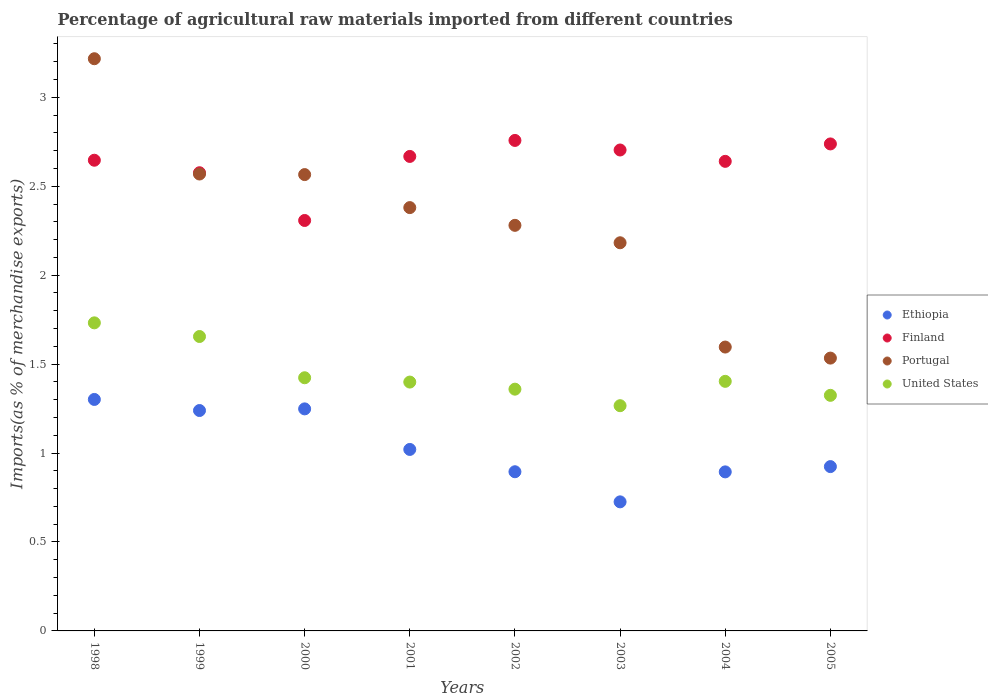How many different coloured dotlines are there?
Ensure brevity in your answer.  4. What is the percentage of imports to different countries in United States in 1999?
Ensure brevity in your answer.  1.66. Across all years, what is the maximum percentage of imports to different countries in Portugal?
Provide a short and direct response. 3.22. Across all years, what is the minimum percentage of imports to different countries in Portugal?
Your response must be concise. 1.53. In which year was the percentage of imports to different countries in Ethiopia minimum?
Offer a very short reply. 2003. What is the total percentage of imports to different countries in Finland in the graph?
Your answer should be compact. 21.04. What is the difference between the percentage of imports to different countries in Finland in 1998 and that in 2005?
Ensure brevity in your answer.  -0.09. What is the difference between the percentage of imports to different countries in Finland in 1999 and the percentage of imports to different countries in United States in 2000?
Provide a short and direct response. 1.15. What is the average percentage of imports to different countries in Portugal per year?
Make the answer very short. 2.29. In the year 2001, what is the difference between the percentage of imports to different countries in United States and percentage of imports to different countries in Finland?
Provide a short and direct response. -1.27. In how many years, is the percentage of imports to different countries in United States greater than 1.1 %?
Offer a very short reply. 8. What is the ratio of the percentage of imports to different countries in Portugal in 2001 to that in 2005?
Keep it short and to the point. 1.55. Is the percentage of imports to different countries in United States in 2002 less than that in 2003?
Provide a short and direct response. No. What is the difference between the highest and the second highest percentage of imports to different countries in Ethiopia?
Offer a terse response. 0.05. What is the difference between the highest and the lowest percentage of imports to different countries in Portugal?
Provide a succinct answer. 1.68. Is the sum of the percentage of imports to different countries in Portugal in 2001 and 2005 greater than the maximum percentage of imports to different countries in Finland across all years?
Offer a terse response. Yes. Is it the case that in every year, the sum of the percentage of imports to different countries in United States and percentage of imports to different countries in Portugal  is greater than the sum of percentage of imports to different countries in Finland and percentage of imports to different countries in Ethiopia?
Offer a terse response. No. Does the percentage of imports to different countries in Portugal monotonically increase over the years?
Your answer should be very brief. No. What is the difference between two consecutive major ticks on the Y-axis?
Offer a very short reply. 0.5. Are the values on the major ticks of Y-axis written in scientific E-notation?
Your answer should be compact. No. Does the graph contain any zero values?
Your response must be concise. No. How many legend labels are there?
Provide a short and direct response. 4. What is the title of the graph?
Offer a terse response. Percentage of agricultural raw materials imported from different countries. What is the label or title of the X-axis?
Offer a very short reply. Years. What is the label or title of the Y-axis?
Offer a very short reply. Imports(as % of merchandise exports). What is the Imports(as % of merchandise exports) in Ethiopia in 1998?
Provide a succinct answer. 1.3. What is the Imports(as % of merchandise exports) of Finland in 1998?
Keep it short and to the point. 2.65. What is the Imports(as % of merchandise exports) of Portugal in 1998?
Your response must be concise. 3.22. What is the Imports(as % of merchandise exports) of United States in 1998?
Your response must be concise. 1.73. What is the Imports(as % of merchandise exports) of Ethiopia in 1999?
Give a very brief answer. 1.24. What is the Imports(as % of merchandise exports) in Finland in 1999?
Make the answer very short. 2.58. What is the Imports(as % of merchandise exports) in Portugal in 1999?
Your answer should be compact. 2.57. What is the Imports(as % of merchandise exports) of United States in 1999?
Make the answer very short. 1.66. What is the Imports(as % of merchandise exports) in Ethiopia in 2000?
Make the answer very short. 1.25. What is the Imports(as % of merchandise exports) of Finland in 2000?
Your answer should be compact. 2.31. What is the Imports(as % of merchandise exports) in Portugal in 2000?
Provide a short and direct response. 2.57. What is the Imports(as % of merchandise exports) of United States in 2000?
Give a very brief answer. 1.42. What is the Imports(as % of merchandise exports) in Ethiopia in 2001?
Offer a very short reply. 1.02. What is the Imports(as % of merchandise exports) in Finland in 2001?
Your answer should be compact. 2.67. What is the Imports(as % of merchandise exports) in Portugal in 2001?
Provide a short and direct response. 2.38. What is the Imports(as % of merchandise exports) in United States in 2001?
Make the answer very short. 1.4. What is the Imports(as % of merchandise exports) of Ethiopia in 2002?
Your response must be concise. 0.89. What is the Imports(as % of merchandise exports) of Finland in 2002?
Give a very brief answer. 2.76. What is the Imports(as % of merchandise exports) in Portugal in 2002?
Make the answer very short. 2.28. What is the Imports(as % of merchandise exports) in United States in 2002?
Give a very brief answer. 1.36. What is the Imports(as % of merchandise exports) in Ethiopia in 2003?
Offer a very short reply. 0.73. What is the Imports(as % of merchandise exports) of Finland in 2003?
Provide a short and direct response. 2.7. What is the Imports(as % of merchandise exports) in Portugal in 2003?
Offer a terse response. 2.18. What is the Imports(as % of merchandise exports) of United States in 2003?
Provide a succinct answer. 1.27. What is the Imports(as % of merchandise exports) in Ethiopia in 2004?
Offer a terse response. 0.89. What is the Imports(as % of merchandise exports) in Finland in 2004?
Ensure brevity in your answer.  2.64. What is the Imports(as % of merchandise exports) of Portugal in 2004?
Your response must be concise. 1.6. What is the Imports(as % of merchandise exports) in United States in 2004?
Give a very brief answer. 1.4. What is the Imports(as % of merchandise exports) of Ethiopia in 2005?
Give a very brief answer. 0.92. What is the Imports(as % of merchandise exports) of Finland in 2005?
Provide a succinct answer. 2.74. What is the Imports(as % of merchandise exports) in Portugal in 2005?
Keep it short and to the point. 1.53. What is the Imports(as % of merchandise exports) of United States in 2005?
Your response must be concise. 1.32. Across all years, what is the maximum Imports(as % of merchandise exports) in Ethiopia?
Your response must be concise. 1.3. Across all years, what is the maximum Imports(as % of merchandise exports) of Finland?
Provide a short and direct response. 2.76. Across all years, what is the maximum Imports(as % of merchandise exports) in Portugal?
Offer a very short reply. 3.22. Across all years, what is the maximum Imports(as % of merchandise exports) in United States?
Give a very brief answer. 1.73. Across all years, what is the minimum Imports(as % of merchandise exports) in Ethiopia?
Your response must be concise. 0.73. Across all years, what is the minimum Imports(as % of merchandise exports) of Finland?
Provide a short and direct response. 2.31. Across all years, what is the minimum Imports(as % of merchandise exports) of Portugal?
Ensure brevity in your answer.  1.53. Across all years, what is the minimum Imports(as % of merchandise exports) in United States?
Keep it short and to the point. 1.27. What is the total Imports(as % of merchandise exports) of Ethiopia in the graph?
Your answer should be compact. 8.25. What is the total Imports(as % of merchandise exports) in Finland in the graph?
Your response must be concise. 21.04. What is the total Imports(as % of merchandise exports) in Portugal in the graph?
Your response must be concise. 18.32. What is the total Imports(as % of merchandise exports) of United States in the graph?
Your response must be concise. 11.56. What is the difference between the Imports(as % of merchandise exports) in Ethiopia in 1998 and that in 1999?
Your answer should be very brief. 0.06. What is the difference between the Imports(as % of merchandise exports) of Finland in 1998 and that in 1999?
Your answer should be compact. 0.07. What is the difference between the Imports(as % of merchandise exports) in Portugal in 1998 and that in 1999?
Provide a succinct answer. 0.65. What is the difference between the Imports(as % of merchandise exports) of United States in 1998 and that in 1999?
Offer a terse response. 0.08. What is the difference between the Imports(as % of merchandise exports) of Ethiopia in 1998 and that in 2000?
Ensure brevity in your answer.  0.05. What is the difference between the Imports(as % of merchandise exports) of Finland in 1998 and that in 2000?
Your response must be concise. 0.34. What is the difference between the Imports(as % of merchandise exports) in Portugal in 1998 and that in 2000?
Ensure brevity in your answer.  0.65. What is the difference between the Imports(as % of merchandise exports) of United States in 1998 and that in 2000?
Your response must be concise. 0.31. What is the difference between the Imports(as % of merchandise exports) in Ethiopia in 1998 and that in 2001?
Offer a terse response. 0.28. What is the difference between the Imports(as % of merchandise exports) in Finland in 1998 and that in 2001?
Ensure brevity in your answer.  -0.02. What is the difference between the Imports(as % of merchandise exports) of Portugal in 1998 and that in 2001?
Offer a terse response. 0.84. What is the difference between the Imports(as % of merchandise exports) of United States in 1998 and that in 2001?
Provide a short and direct response. 0.33. What is the difference between the Imports(as % of merchandise exports) of Ethiopia in 1998 and that in 2002?
Provide a short and direct response. 0.41. What is the difference between the Imports(as % of merchandise exports) in Finland in 1998 and that in 2002?
Make the answer very short. -0.11. What is the difference between the Imports(as % of merchandise exports) in Portugal in 1998 and that in 2002?
Provide a short and direct response. 0.94. What is the difference between the Imports(as % of merchandise exports) of United States in 1998 and that in 2002?
Your answer should be compact. 0.37. What is the difference between the Imports(as % of merchandise exports) of Ethiopia in 1998 and that in 2003?
Your answer should be very brief. 0.58. What is the difference between the Imports(as % of merchandise exports) in Finland in 1998 and that in 2003?
Offer a terse response. -0.06. What is the difference between the Imports(as % of merchandise exports) in Portugal in 1998 and that in 2003?
Your answer should be compact. 1.03. What is the difference between the Imports(as % of merchandise exports) in United States in 1998 and that in 2003?
Your answer should be compact. 0.47. What is the difference between the Imports(as % of merchandise exports) in Ethiopia in 1998 and that in 2004?
Offer a terse response. 0.41. What is the difference between the Imports(as % of merchandise exports) of Finland in 1998 and that in 2004?
Provide a short and direct response. 0.01. What is the difference between the Imports(as % of merchandise exports) of Portugal in 1998 and that in 2004?
Your answer should be compact. 1.62. What is the difference between the Imports(as % of merchandise exports) of United States in 1998 and that in 2004?
Give a very brief answer. 0.33. What is the difference between the Imports(as % of merchandise exports) in Ethiopia in 1998 and that in 2005?
Offer a very short reply. 0.38. What is the difference between the Imports(as % of merchandise exports) in Finland in 1998 and that in 2005?
Offer a very short reply. -0.09. What is the difference between the Imports(as % of merchandise exports) in Portugal in 1998 and that in 2005?
Ensure brevity in your answer.  1.68. What is the difference between the Imports(as % of merchandise exports) of United States in 1998 and that in 2005?
Make the answer very short. 0.41. What is the difference between the Imports(as % of merchandise exports) of Ethiopia in 1999 and that in 2000?
Your response must be concise. -0.01. What is the difference between the Imports(as % of merchandise exports) in Finland in 1999 and that in 2000?
Offer a very short reply. 0.27. What is the difference between the Imports(as % of merchandise exports) of Portugal in 1999 and that in 2000?
Provide a short and direct response. 0. What is the difference between the Imports(as % of merchandise exports) in United States in 1999 and that in 2000?
Keep it short and to the point. 0.23. What is the difference between the Imports(as % of merchandise exports) in Ethiopia in 1999 and that in 2001?
Your answer should be very brief. 0.22. What is the difference between the Imports(as % of merchandise exports) in Finland in 1999 and that in 2001?
Make the answer very short. -0.09. What is the difference between the Imports(as % of merchandise exports) in Portugal in 1999 and that in 2001?
Offer a very short reply. 0.19. What is the difference between the Imports(as % of merchandise exports) in United States in 1999 and that in 2001?
Give a very brief answer. 0.26. What is the difference between the Imports(as % of merchandise exports) of Ethiopia in 1999 and that in 2002?
Provide a succinct answer. 0.34. What is the difference between the Imports(as % of merchandise exports) in Finland in 1999 and that in 2002?
Ensure brevity in your answer.  -0.18. What is the difference between the Imports(as % of merchandise exports) in Portugal in 1999 and that in 2002?
Your response must be concise. 0.29. What is the difference between the Imports(as % of merchandise exports) of United States in 1999 and that in 2002?
Make the answer very short. 0.3. What is the difference between the Imports(as % of merchandise exports) in Ethiopia in 1999 and that in 2003?
Provide a succinct answer. 0.51. What is the difference between the Imports(as % of merchandise exports) in Finland in 1999 and that in 2003?
Provide a short and direct response. -0.13. What is the difference between the Imports(as % of merchandise exports) of Portugal in 1999 and that in 2003?
Provide a short and direct response. 0.39. What is the difference between the Imports(as % of merchandise exports) of United States in 1999 and that in 2003?
Offer a very short reply. 0.39. What is the difference between the Imports(as % of merchandise exports) in Ethiopia in 1999 and that in 2004?
Offer a terse response. 0.34. What is the difference between the Imports(as % of merchandise exports) in Finland in 1999 and that in 2004?
Offer a terse response. -0.06. What is the difference between the Imports(as % of merchandise exports) of Portugal in 1999 and that in 2004?
Ensure brevity in your answer.  0.97. What is the difference between the Imports(as % of merchandise exports) of United States in 1999 and that in 2004?
Offer a very short reply. 0.25. What is the difference between the Imports(as % of merchandise exports) of Ethiopia in 1999 and that in 2005?
Offer a terse response. 0.32. What is the difference between the Imports(as % of merchandise exports) of Finland in 1999 and that in 2005?
Provide a short and direct response. -0.16. What is the difference between the Imports(as % of merchandise exports) of Portugal in 1999 and that in 2005?
Make the answer very short. 1.03. What is the difference between the Imports(as % of merchandise exports) in United States in 1999 and that in 2005?
Your response must be concise. 0.33. What is the difference between the Imports(as % of merchandise exports) in Ethiopia in 2000 and that in 2001?
Give a very brief answer. 0.23. What is the difference between the Imports(as % of merchandise exports) in Finland in 2000 and that in 2001?
Offer a terse response. -0.36. What is the difference between the Imports(as % of merchandise exports) in Portugal in 2000 and that in 2001?
Give a very brief answer. 0.19. What is the difference between the Imports(as % of merchandise exports) of United States in 2000 and that in 2001?
Offer a terse response. 0.02. What is the difference between the Imports(as % of merchandise exports) in Ethiopia in 2000 and that in 2002?
Offer a terse response. 0.35. What is the difference between the Imports(as % of merchandise exports) of Finland in 2000 and that in 2002?
Provide a short and direct response. -0.45. What is the difference between the Imports(as % of merchandise exports) in Portugal in 2000 and that in 2002?
Keep it short and to the point. 0.29. What is the difference between the Imports(as % of merchandise exports) of United States in 2000 and that in 2002?
Ensure brevity in your answer.  0.06. What is the difference between the Imports(as % of merchandise exports) of Ethiopia in 2000 and that in 2003?
Your answer should be compact. 0.52. What is the difference between the Imports(as % of merchandise exports) in Finland in 2000 and that in 2003?
Keep it short and to the point. -0.4. What is the difference between the Imports(as % of merchandise exports) in Portugal in 2000 and that in 2003?
Offer a terse response. 0.38. What is the difference between the Imports(as % of merchandise exports) in United States in 2000 and that in 2003?
Offer a very short reply. 0.16. What is the difference between the Imports(as % of merchandise exports) in Ethiopia in 2000 and that in 2004?
Give a very brief answer. 0.35. What is the difference between the Imports(as % of merchandise exports) in Finland in 2000 and that in 2004?
Your answer should be compact. -0.33. What is the difference between the Imports(as % of merchandise exports) in Portugal in 2000 and that in 2004?
Ensure brevity in your answer.  0.97. What is the difference between the Imports(as % of merchandise exports) of United States in 2000 and that in 2004?
Your response must be concise. 0.02. What is the difference between the Imports(as % of merchandise exports) of Ethiopia in 2000 and that in 2005?
Ensure brevity in your answer.  0.32. What is the difference between the Imports(as % of merchandise exports) of Finland in 2000 and that in 2005?
Provide a short and direct response. -0.43. What is the difference between the Imports(as % of merchandise exports) in Portugal in 2000 and that in 2005?
Provide a short and direct response. 1.03. What is the difference between the Imports(as % of merchandise exports) of United States in 2000 and that in 2005?
Make the answer very short. 0.1. What is the difference between the Imports(as % of merchandise exports) in Ethiopia in 2001 and that in 2002?
Make the answer very short. 0.13. What is the difference between the Imports(as % of merchandise exports) in Finland in 2001 and that in 2002?
Provide a succinct answer. -0.09. What is the difference between the Imports(as % of merchandise exports) of Portugal in 2001 and that in 2002?
Provide a short and direct response. 0.1. What is the difference between the Imports(as % of merchandise exports) in United States in 2001 and that in 2002?
Ensure brevity in your answer.  0.04. What is the difference between the Imports(as % of merchandise exports) of Ethiopia in 2001 and that in 2003?
Ensure brevity in your answer.  0.29. What is the difference between the Imports(as % of merchandise exports) of Finland in 2001 and that in 2003?
Ensure brevity in your answer.  -0.04. What is the difference between the Imports(as % of merchandise exports) in Portugal in 2001 and that in 2003?
Your response must be concise. 0.2. What is the difference between the Imports(as % of merchandise exports) in United States in 2001 and that in 2003?
Provide a succinct answer. 0.13. What is the difference between the Imports(as % of merchandise exports) of Ethiopia in 2001 and that in 2004?
Provide a succinct answer. 0.13. What is the difference between the Imports(as % of merchandise exports) of Finland in 2001 and that in 2004?
Ensure brevity in your answer.  0.03. What is the difference between the Imports(as % of merchandise exports) in Portugal in 2001 and that in 2004?
Provide a short and direct response. 0.78. What is the difference between the Imports(as % of merchandise exports) of United States in 2001 and that in 2004?
Keep it short and to the point. -0. What is the difference between the Imports(as % of merchandise exports) in Ethiopia in 2001 and that in 2005?
Offer a terse response. 0.1. What is the difference between the Imports(as % of merchandise exports) in Finland in 2001 and that in 2005?
Ensure brevity in your answer.  -0.07. What is the difference between the Imports(as % of merchandise exports) of Portugal in 2001 and that in 2005?
Give a very brief answer. 0.85. What is the difference between the Imports(as % of merchandise exports) of United States in 2001 and that in 2005?
Provide a succinct answer. 0.07. What is the difference between the Imports(as % of merchandise exports) in Ethiopia in 2002 and that in 2003?
Give a very brief answer. 0.17. What is the difference between the Imports(as % of merchandise exports) of Finland in 2002 and that in 2003?
Keep it short and to the point. 0.05. What is the difference between the Imports(as % of merchandise exports) of Portugal in 2002 and that in 2003?
Ensure brevity in your answer.  0.1. What is the difference between the Imports(as % of merchandise exports) of United States in 2002 and that in 2003?
Provide a succinct answer. 0.09. What is the difference between the Imports(as % of merchandise exports) in Ethiopia in 2002 and that in 2004?
Provide a short and direct response. 0. What is the difference between the Imports(as % of merchandise exports) in Finland in 2002 and that in 2004?
Offer a very short reply. 0.12. What is the difference between the Imports(as % of merchandise exports) in Portugal in 2002 and that in 2004?
Make the answer very short. 0.68. What is the difference between the Imports(as % of merchandise exports) in United States in 2002 and that in 2004?
Offer a terse response. -0.04. What is the difference between the Imports(as % of merchandise exports) in Ethiopia in 2002 and that in 2005?
Your response must be concise. -0.03. What is the difference between the Imports(as % of merchandise exports) of Finland in 2002 and that in 2005?
Your answer should be very brief. 0.02. What is the difference between the Imports(as % of merchandise exports) of Portugal in 2002 and that in 2005?
Make the answer very short. 0.75. What is the difference between the Imports(as % of merchandise exports) of United States in 2002 and that in 2005?
Provide a short and direct response. 0.03. What is the difference between the Imports(as % of merchandise exports) of Ethiopia in 2003 and that in 2004?
Your response must be concise. -0.17. What is the difference between the Imports(as % of merchandise exports) in Finland in 2003 and that in 2004?
Give a very brief answer. 0.06. What is the difference between the Imports(as % of merchandise exports) in Portugal in 2003 and that in 2004?
Your answer should be compact. 0.59. What is the difference between the Imports(as % of merchandise exports) in United States in 2003 and that in 2004?
Your response must be concise. -0.14. What is the difference between the Imports(as % of merchandise exports) in Ethiopia in 2003 and that in 2005?
Your response must be concise. -0.2. What is the difference between the Imports(as % of merchandise exports) of Finland in 2003 and that in 2005?
Provide a succinct answer. -0.03. What is the difference between the Imports(as % of merchandise exports) in Portugal in 2003 and that in 2005?
Offer a terse response. 0.65. What is the difference between the Imports(as % of merchandise exports) in United States in 2003 and that in 2005?
Your answer should be compact. -0.06. What is the difference between the Imports(as % of merchandise exports) of Ethiopia in 2004 and that in 2005?
Provide a succinct answer. -0.03. What is the difference between the Imports(as % of merchandise exports) in Finland in 2004 and that in 2005?
Offer a very short reply. -0.1. What is the difference between the Imports(as % of merchandise exports) of Portugal in 2004 and that in 2005?
Give a very brief answer. 0.06. What is the difference between the Imports(as % of merchandise exports) of United States in 2004 and that in 2005?
Your answer should be very brief. 0.08. What is the difference between the Imports(as % of merchandise exports) of Ethiopia in 1998 and the Imports(as % of merchandise exports) of Finland in 1999?
Give a very brief answer. -1.27. What is the difference between the Imports(as % of merchandise exports) in Ethiopia in 1998 and the Imports(as % of merchandise exports) in Portugal in 1999?
Your answer should be very brief. -1.27. What is the difference between the Imports(as % of merchandise exports) in Ethiopia in 1998 and the Imports(as % of merchandise exports) in United States in 1999?
Your response must be concise. -0.35. What is the difference between the Imports(as % of merchandise exports) of Finland in 1998 and the Imports(as % of merchandise exports) of Portugal in 1999?
Make the answer very short. 0.08. What is the difference between the Imports(as % of merchandise exports) in Portugal in 1998 and the Imports(as % of merchandise exports) in United States in 1999?
Your response must be concise. 1.56. What is the difference between the Imports(as % of merchandise exports) in Ethiopia in 1998 and the Imports(as % of merchandise exports) in Finland in 2000?
Give a very brief answer. -1.01. What is the difference between the Imports(as % of merchandise exports) of Ethiopia in 1998 and the Imports(as % of merchandise exports) of Portugal in 2000?
Your answer should be compact. -1.26. What is the difference between the Imports(as % of merchandise exports) in Ethiopia in 1998 and the Imports(as % of merchandise exports) in United States in 2000?
Ensure brevity in your answer.  -0.12. What is the difference between the Imports(as % of merchandise exports) of Finland in 1998 and the Imports(as % of merchandise exports) of Portugal in 2000?
Ensure brevity in your answer.  0.08. What is the difference between the Imports(as % of merchandise exports) in Finland in 1998 and the Imports(as % of merchandise exports) in United States in 2000?
Your answer should be very brief. 1.22. What is the difference between the Imports(as % of merchandise exports) of Portugal in 1998 and the Imports(as % of merchandise exports) of United States in 2000?
Provide a succinct answer. 1.79. What is the difference between the Imports(as % of merchandise exports) in Ethiopia in 1998 and the Imports(as % of merchandise exports) in Finland in 2001?
Provide a succinct answer. -1.37. What is the difference between the Imports(as % of merchandise exports) in Ethiopia in 1998 and the Imports(as % of merchandise exports) in Portugal in 2001?
Give a very brief answer. -1.08. What is the difference between the Imports(as % of merchandise exports) in Ethiopia in 1998 and the Imports(as % of merchandise exports) in United States in 2001?
Give a very brief answer. -0.1. What is the difference between the Imports(as % of merchandise exports) in Finland in 1998 and the Imports(as % of merchandise exports) in Portugal in 2001?
Provide a short and direct response. 0.27. What is the difference between the Imports(as % of merchandise exports) of Finland in 1998 and the Imports(as % of merchandise exports) of United States in 2001?
Ensure brevity in your answer.  1.25. What is the difference between the Imports(as % of merchandise exports) in Portugal in 1998 and the Imports(as % of merchandise exports) in United States in 2001?
Your response must be concise. 1.82. What is the difference between the Imports(as % of merchandise exports) in Ethiopia in 1998 and the Imports(as % of merchandise exports) in Finland in 2002?
Your response must be concise. -1.46. What is the difference between the Imports(as % of merchandise exports) in Ethiopia in 1998 and the Imports(as % of merchandise exports) in Portugal in 2002?
Your answer should be very brief. -0.98. What is the difference between the Imports(as % of merchandise exports) of Ethiopia in 1998 and the Imports(as % of merchandise exports) of United States in 2002?
Ensure brevity in your answer.  -0.06. What is the difference between the Imports(as % of merchandise exports) in Finland in 1998 and the Imports(as % of merchandise exports) in Portugal in 2002?
Ensure brevity in your answer.  0.37. What is the difference between the Imports(as % of merchandise exports) in Finland in 1998 and the Imports(as % of merchandise exports) in United States in 2002?
Give a very brief answer. 1.29. What is the difference between the Imports(as % of merchandise exports) in Portugal in 1998 and the Imports(as % of merchandise exports) in United States in 2002?
Offer a very short reply. 1.86. What is the difference between the Imports(as % of merchandise exports) in Ethiopia in 1998 and the Imports(as % of merchandise exports) in Finland in 2003?
Give a very brief answer. -1.4. What is the difference between the Imports(as % of merchandise exports) in Ethiopia in 1998 and the Imports(as % of merchandise exports) in Portugal in 2003?
Your answer should be very brief. -0.88. What is the difference between the Imports(as % of merchandise exports) of Ethiopia in 1998 and the Imports(as % of merchandise exports) of United States in 2003?
Make the answer very short. 0.04. What is the difference between the Imports(as % of merchandise exports) of Finland in 1998 and the Imports(as % of merchandise exports) of Portugal in 2003?
Make the answer very short. 0.46. What is the difference between the Imports(as % of merchandise exports) of Finland in 1998 and the Imports(as % of merchandise exports) of United States in 2003?
Your answer should be compact. 1.38. What is the difference between the Imports(as % of merchandise exports) of Portugal in 1998 and the Imports(as % of merchandise exports) of United States in 2003?
Your answer should be very brief. 1.95. What is the difference between the Imports(as % of merchandise exports) in Ethiopia in 1998 and the Imports(as % of merchandise exports) in Finland in 2004?
Offer a terse response. -1.34. What is the difference between the Imports(as % of merchandise exports) in Ethiopia in 1998 and the Imports(as % of merchandise exports) in Portugal in 2004?
Make the answer very short. -0.29. What is the difference between the Imports(as % of merchandise exports) in Ethiopia in 1998 and the Imports(as % of merchandise exports) in United States in 2004?
Your answer should be compact. -0.1. What is the difference between the Imports(as % of merchandise exports) of Finland in 1998 and the Imports(as % of merchandise exports) of Portugal in 2004?
Provide a succinct answer. 1.05. What is the difference between the Imports(as % of merchandise exports) in Finland in 1998 and the Imports(as % of merchandise exports) in United States in 2004?
Your answer should be very brief. 1.24. What is the difference between the Imports(as % of merchandise exports) in Portugal in 1998 and the Imports(as % of merchandise exports) in United States in 2004?
Your response must be concise. 1.81. What is the difference between the Imports(as % of merchandise exports) of Ethiopia in 1998 and the Imports(as % of merchandise exports) of Finland in 2005?
Keep it short and to the point. -1.44. What is the difference between the Imports(as % of merchandise exports) in Ethiopia in 1998 and the Imports(as % of merchandise exports) in Portugal in 2005?
Offer a terse response. -0.23. What is the difference between the Imports(as % of merchandise exports) of Ethiopia in 1998 and the Imports(as % of merchandise exports) of United States in 2005?
Ensure brevity in your answer.  -0.02. What is the difference between the Imports(as % of merchandise exports) in Finland in 1998 and the Imports(as % of merchandise exports) in Portugal in 2005?
Provide a succinct answer. 1.11. What is the difference between the Imports(as % of merchandise exports) of Finland in 1998 and the Imports(as % of merchandise exports) of United States in 2005?
Offer a terse response. 1.32. What is the difference between the Imports(as % of merchandise exports) in Portugal in 1998 and the Imports(as % of merchandise exports) in United States in 2005?
Offer a terse response. 1.89. What is the difference between the Imports(as % of merchandise exports) in Ethiopia in 1999 and the Imports(as % of merchandise exports) in Finland in 2000?
Your answer should be compact. -1.07. What is the difference between the Imports(as % of merchandise exports) in Ethiopia in 1999 and the Imports(as % of merchandise exports) in Portugal in 2000?
Offer a terse response. -1.33. What is the difference between the Imports(as % of merchandise exports) in Ethiopia in 1999 and the Imports(as % of merchandise exports) in United States in 2000?
Offer a very short reply. -0.18. What is the difference between the Imports(as % of merchandise exports) in Finland in 1999 and the Imports(as % of merchandise exports) in Portugal in 2000?
Provide a succinct answer. 0.01. What is the difference between the Imports(as % of merchandise exports) of Finland in 1999 and the Imports(as % of merchandise exports) of United States in 2000?
Provide a short and direct response. 1.15. What is the difference between the Imports(as % of merchandise exports) in Portugal in 1999 and the Imports(as % of merchandise exports) in United States in 2000?
Offer a very short reply. 1.15. What is the difference between the Imports(as % of merchandise exports) in Ethiopia in 1999 and the Imports(as % of merchandise exports) in Finland in 2001?
Your answer should be very brief. -1.43. What is the difference between the Imports(as % of merchandise exports) in Ethiopia in 1999 and the Imports(as % of merchandise exports) in Portugal in 2001?
Your answer should be compact. -1.14. What is the difference between the Imports(as % of merchandise exports) in Ethiopia in 1999 and the Imports(as % of merchandise exports) in United States in 2001?
Give a very brief answer. -0.16. What is the difference between the Imports(as % of merchandise exports) in Finland in 1999 and the Imports(as % of merchandise exports) in Portugal in 2001?
Provide a succinct answer. 0.2. What is the difference between the Imports(as % of merchandise exports) of Finland in 1999 and the Imports(as % of merchandise exports) of United States in 2001?
Give a very brief answer. 1.18. What is the difference between the Imports(as % of merchandise exports) of Portugal in 1999 and the Imports(as % of merchandise exports) of United States in 2001?
Provide a short and direct response. 1.17. What is the difference between the Imports(as % of merchandise exports) of Ethiopia in 1999 and the Imports(as % of merchandise exports) of Finland in 2002?
Give a very brief answer. -1.52. What is the difference between the Imports(as % of merchandise exports) in Ethiopia in 1999 and the Imports(as % of merchandise exports) in Portugal in 2002?
Your answer should be compact. -1.04. What is the difference between the Imports(as % of merchandise exports) of Ethiopia in 1999 and the Imports(as % of merchandise exports) of United States in 2002?
Your response must be concise. -0.12. What is the difference between the Imports(as % of merchandise exports) of Finland in 1999 and the Imports(as % of merchandise exports) of Portugal in 2002?
Your response must be concise. 0.3. What is the difference between the Imports(as % of merchandise exports) of Finland in 1999 and the Imports(as % of merchandise exports) of United States in 2002?
Your answer should be compact. 1.22. What is the difference between the Imports(as % of merchandise exports) in Portugal in 1999 and the Imports(as % of merchandise exports) in United States in 2002?
Give a very brief answer. 1.21. What is the difference between the Imports(as % of merchandise exports) of Ethiopia in 1999 and the Imports(as % of merchandise exports) of Finland in 2003?
Your answer should be compact. -1.46. What is the difference between the Imports(as % of merchandise exports) of Ethiopia in 1999 and the Imports(as % of merchandise exports) of Portugal in 2003?
Keep it short and to the point. -0.94. What is the difference between the Imports(as % of merchandise exports) of Ethiopia in 1999 and the Imports(as % of merchandise exports) of United States in 2003?
Provide a succinct answer. -0.03. What is the difference between the Imports(as % of merchandise exports) of Finland in 1999 and the Imports(as % of merchandise exports) of Portugal in 2003?
Give a very brief answer. 0.39. What is the difference between the Imports(as % of merchandise exports) of Finland in 1999 and the Imports(as % of merchandise exports) of United States in 2003?
Your response must be concise. 1.31. What is the difference between the Imports(as % of merchandise exports) of Portugal in 1999 and the Imports(as % of merchandise exports) of United States in 2003?
Offer a terse response. 1.3. What is the difference between the Imports(as % of merchandise exports) in Ethiopia in 1999 and the Imports(as % of merchandise exports) in Finland in 2004?
Ensure brevity in your answer.  -1.4. What is the difference between the Imports(as % of merchandise exports) of Ethiopia in 1999 and the Imports(as % of merchandise exports) of Portugal in 2004?
Provide a succinct answer. -0.36. What is the difference between the Imports(as % of merchandise exports) of Ethiopia in 1999 and the Imports(as % of merchandise exports) of United States in 2004?
Keep it short and to the point. -0.16. What is the difference between the Imports(as % of merchandise exports) in Finland in 1999 and the Imports(as % of merchandise exports) in Portugal in 2004?
Provide a short and direct response. 0.98. What is the difference between the Imports(as % of merchandise exports) of Finland in 1999 and the Imports(as % of merchandise exports) of United States in 2004?
Offer a very short reply. 1.17. What is the difference between the Imports(as % of merchandise exports) of Portugal in 1999 and the Imports(as % of merchandise exports) of United States in 2004?
Make the answer very short. 1.17. What is the difference between the Imports(as % of merchandise exports) in Ethiopia in 1999 and the Imports(as % of merchandise exports) in Finland in 2005?
Offer a terse response. -1.5. What is the difference between the Imports(as % of merchandise exports) of Ethiopia in 1999 and the Imports(as % of merchandise exports) of Portugal in 2005?
Offer a very short reply. -0.29. What is the difference between the Imports(as % of merchandise exports) of Ethiopia in 1999 and the Imports(as % of merchandise exports) of United States in 2005?
Your response must be concise. -0.09. What is the difference between the Imports(as % of merchandise exports) of Finland in 1999 and the Imports(as % of merchandise exports) of Portugal in 2005?
Your answer should be compact. 1.04. What is the difference between the Imports(as % of merchandise exports) of Finland in 1999 and the Imports(as % of merchandise exports) of United States in 2005?
Your response must be concise. 1.25. What is the difference between the Imports(as % of merchandise exports) of Portugal in 1999 and the Imports(as % of merchandise exports) of United States in 2005?
Provide a succinct answer. 1.24. What is the difference between the Imports(as % of merchandise exports) in Ethiopia in 2000 and the Imports(as % of merchandise exports) in Finland in 2001?
Your answer should be compact. -1.42. What is the difference between the Imports(as % of merchandise exports) of Ethiopia in 2000 and the Imports(as % of merchandise exports) of Portugal in 2001?
Give a very brief answer. -1.13. What is the difference between the Imports(as % of merchandise exports) of Ethiopia in 2000 and the Imports(as % of merchandise exports) of United States in 2001?
Keep it short and to the point. -0.15. What is the difference between the Imports(as % of merchandise exports) in Finland in 2000 and the Imports(as % of merchandise exports) in Portugal in 2001?
Offer a terse response. -0.07. What is the difference between the Imports(as % of merchandise exports) of Finland in 2000 and the Imports(as % of merchandise exports) of United States in 2001?
Your answer should be compact. 0.91. What is the difference between the Imports(as % of merchandise exports) of Portugal in 2000 and the Imports(as % of merchandise exports) of United States in 2001?
Your answer should be compact. 1.17. What is the difference between the Imports(as % of merchandise exports) of Ethiopia in 2000 and the Imports(as % of merchandise exports) of Finland in 2002?
Offer a terse response. -1.51. What is the difference between the Imports(as % of merchandise exports) in Ethiopia in 2000 and the Imports(as % of merchandise exports) in Portugal in 2002?
Your answer should be compact. -1.03. What is the difference between the Imports(as % of merchandise exports) in Ethiopia in 2000 and the Imports(as % of merchandise exports) in United States in 2002?
Provide a short and direct response. -0.11. What is the difference between the Imports(as % of merchandise exports) in Finland in 2000 and the Imports(as % of merchandise exports) in Portugal in 2002?
Your answer should be compact. 0.03. What is the difference between the Imports(as % of merchandise exports) in Finland in 2000 and the Imports(as % of merchandise exports) in United States in 2002?
Your response must be concise. 0.95. What is the difference between the Imports(as % of merchandise exports) of Portugal in 2000 and the Imports(as % of merchandise exports) of United States in 2002?
Your answer should be compact. 1.21. What is the difference between the Imports(as % of merchandise exports) in Ethiopia in 2000 and the Imports(as % of merchandise exports) in Finland in 2003?
Provide a succinct answer. -1.46. What is the difference between the Imports(as % of merchandise exports) in Ethiopia in 2000 and the Imports(as % of merchandise exports) in Portugal in 2003?
Provide a short and direct response. -0.93. What is the difference between the Imports(as % of merchandise exports) of Ethiopia in 2000 and the Imports(as % of merchandise exports) of United States in 2003?
Keep it short and to the point. -0.02. What is the difference between the Imports(as % of merchandise exports) in Finland in 2000 and the Imports(as % of merchandise exports) in Portugal in 2003?
Your response must be concise. 0.13. What is the difference between the Imports(as % of merchandise exports) in Finland in 2000 and the Imports(as % of merchandise exports) in United States in 2003?
Your response must be concise. 1.04. What is the difference between the Imports(as % of merchandise exports) in Portugal in 2000 and the Imports(as % of merchandise exports) in United States in 2003?
Your answer should be compact. 1.3. What is the difference between the Imports(as % of merchandise exports) in Ethiopia in 2000 and the Imports(as % of merchandise exports) in Finland in 2004?
Ensure brevity in your answer.  -1.39. What is the difference between the Imports(as % of merchandise exports) of Ethiopia in 2000 and the Imports(as % of merchandise exports) of Portugal in 2004?
Make the answer very short. -0.35. What is the difference between the Imports(as % of merchandise exports) in Ethiopia in 2000 and the Imports(as % of merchandise exports) in United States in 2004?
Keep it short and to the point. -0.15. What is the difference between the Imports(as % of merchandise exports) of Finland in 2000 and the Imports(as % of merchandise exports) of Portugal in 2004?
Provide a succinct answer. 0.71. What is the difference between the Imports(as % of merchandise exports) in Finland in 2000 and the Imports(as % of merchandise exports) in United States in 2004?
Provide a succinct answer. 0.9. What is the difference between the Imports(as % of merchandise exports) in Portugal in 2000 and the Imports(as % of merchandise exports) in United States in 2004?
Keep it short and to the point. 1.16. What is the difference between the Imports(as % of merchandise exports) of Ethiopia in 2000 and the Imports(as % of merchandise exports) of Finland in 2005?
Provide a succinct answer. -1.49. What is the difference between the Imports(as % of merchandise exports) in Ethiopia in 2000 and the Imports(as % of merchandise exports) in Portugal in 2005?
Give a very brief answer. -0.29. What is the difference between the Imports(as % of merchandise exports) of Ethiopia in 2000 and the Imports(as % of merchandise exports) of United States in 2005?
Make the answer very short. -0.08. What is the difference between the Imports(as % of merchandise exports) in Finland in 2000 and the Imports(as % of merchandise exports) in Portugal in 2005?
Offer a terse response. 0.77. What is the difference between the Imports(as % of merchandise exports) of Finland in 2000 and the Imports(as % of merchandise exports) of United States in 2005?
Give a very brief answer. 0.98. What is the difference between the Imports(as % of merchandise exports) in Portugal in 2000 and the Imports(as % of merchandise exports) in United States in 2005?
Your answer should be compact. 1.24. What is the difference between the Imports(as % of merchandise exports) in Ethiopia in 2001 and the Imports(as % of merchandise exports) in Finland in 2002?
Keep it short and to the point. -1.74. What is the difference between the Imports(as % of merchandise exports) of Ethiopia in 2001 and the Imports(as % of merchandise exports) of Portugal in 2002?
Provide a succinct answer. -1.26. What is the difference between the Imports(as % of merchandise exports) in Ethiopia in 2001 and the Imports(as % of merchandise exports) in United States in 2002?
Your response must be concise. -0.34. What is the difference between the Imports(as % of merchandise exports) in Finland in 2001 and the Imports(as % of merchandise exports) in Portugal in 2002?
Provide a short and direct response. 0.39. What is the difference between the Imports(as % of merchandise exports) of Finland in 2001 and the Imports(as % of merchandise exports) of United States in 2002?
Provide a succinct answer. 1.31. What is the difference between the Imports(as % of merchandise exports) of Portugal in 2001 and the Imports(as % of merchandise exports) of United States in 2002?
Keep it short and to the point. 1.02. What is the difference between the Imports(as % of merchandise exports) in Ethiopia in 2001 and the Imports(as % of merchandise exports) in Finland in 2003?
Make the answer very short. -1.68. What is the difference between the Imports(as % of merchandise exports) of Ethiopia in 2001 and the Imports(as % of merchandise exports) of Portugal in 2003?
Provide a succinct answer. -1.16. What is the difference between the Imports(as % of merchandise exports) in Ethiopia in 2001 and the Imports(as % of merchandise exports) in United States in 2003?
Your answer should be very brief. -0.25. What is the difference between the Imports(as % of merchandise exports) in Finland in 2001 and the Imports(as % of merchandise exports) in Portugal in 2003?
Make the answer very short. 0.49. What is the difference between the Imports(as % of merchandise exports) in Finland in 2001 and the Imports(as % of merchandise exports) in United States in 2003?
Provide a short and direct response. 1.4. What is the difference between the Imports(as % of merchandise exports) in Portugal in 2001 and the Imports(as % of merchandise exports) in United States in 2003?
Make the answer very short. 1.11. What is the difference between the Imports(as % of merchandise exports) in Ethiopia in 2001 and the Imports(as % of merchandise exports) in Finland in 2004?
Make the answer very short. -1.62. What is the difference between the Imports(as % of merchandise exports) of Ethiopia in 2001 and the Imports(as % of merchandise exports) of Portugal in 2004?
Make the answer very short. -0.58. What is the difference between the Imports(as % of merchandise exports) in Ethiopia in 2001 and the Imports(as % of merchandise exports) in United States in 2004?
Your response must be concise. -0.38. What is the difference between the Imports(as % of merchandise exports) in Finland in 2001 and the Imports(as % of merchandise exports) in Portugal in 2004?
Keep it short and to the point. 1.07. What is the difference between the Imports(as % of merchandise exports) of Finland in 2001 and the Imports(as % of merchandise exports) of United States in 2004?
Provide a succinct answer. 1.26. What is the difference between the Imports(as % of merchandise exports) in Portugal in 2001 and the Imports(as % of merchandise exports) in United States in 2004?
Offer a terse response. 0.98. What is the difference between the Imports(as % of merchandise exports) of Ethiopia in 2001 and the Imports(as % of merchandise exports) of Finland in 2005?
Your answer should be compact. -1.72. What is the difference between the Imports(as % of merchandise exports) in Ethiopia in 2001 and the Imports(as % of merchandise exports) in Portugal in 2005?
Your answer should be compact. -0.51. What is the difference between the Imports(as % of merchandise exports) in Ethiopia in 2001 and the Imports(as % of merchandise exports) in United States in 2005?
Offer a very short reply. -0.3. What is the difference between the Imports(as % of merchandise exports) of Finland in 2001 and the Imports(as % of merchandise exports) of Portugal in 2005?
Provide a short and direct response. 1.13. What is the difference between the Imports(as % of merchandise exports) in Finland in 2001 and the Imports(as % of merchandise exports) in United States in 2005?
Offer a very short reply. 1.34. What is the difference between the Imports(as % of merchandise exports) in Portugal in 2001 and the Imports(as % of merchandise exports) in United States in 2005?
Your response must be concise. 1.06. What is the difference between the Imports(as % of merchandise exports) in Ethiopia in 2002 and the Imports(as % of merchandise exports) in Finland in 2003?
Your answer should be very brief. -1.81. What is the difference between the Imports(as % of merchandise exports) of Ethiopia in 2002 and the Imports(as % of merchandise exports) of Portugal in 2003?
Keep it short and to the point. -1.29. What is the difference between the Imports(as % of merchandise exports) in Ethiopia in 2002 and the Imports(as % of merchandise exports) in United States in 2003?
Your answer should be very brief. -0.37. What is the difference between the Imports(as % of merchandise exports) in Finland in 2002 and the Imports(as % of merchandise exports) in Portugal in 2003?
Your answer should be compact. 0.58. What is the difference between the Imports(as % of merchandise exports) of Finland in 2002 and the Imports(as % of merchandise exports) of United States in 2003?
Your answer should be compact. 1.49. What is the difference between the Imports(as % of merchandise exports) in Portugal in 2002 and the Imports(as % of merchandise exports) in United States in 2003?
Offer a very short reply. 1.01. What is the difference between the Imports(as % of merchandise exports) in Ethiopia in 2002 and the Imports(as % of merchandise exports) in Finland in 2004?
Provide a short and direct response. -1.75. What is the difference between the Imports(as % of merchandise exports) in Ethiopia in 2002 and the Imports(as % of merchandise exports) in Portugal in 2004?
Make the answer very short. -0.7. What is the difference between the Imports(as % of merchandise exports) of Ethiopia in 2002 and the Imports(as % of merchandise exports) of United States in 2004?
Ensure brevity in your answer.  -0.51. What is the difference between the Imports(as % of merchandise exports) in Finland in 2002 and the Imports(as % of merchandise exports) in Portugal in 2004?
Ensure brevity in your answer.  1.16. What is the difference between the Imports(as % of merchandise exports) of Finland in 2002 and the Imports(as % of merchandise exports) of United States in 2004?
Your answer should be very brief. 1.35. What is the difference between the Imports(as % of merchandise exports) of Portugal in 2002 and the Imports(as % of merchandise exports) of United States in 2004?
Offer a terse response. 0.88. What is the difference between the Imports(as % of merchandise exports) of Ethiopia in 2002 and the Imports(as % of merchandise exports) of Finland in 2005?
Your answer should be compact. -1.84. What is the difference between the Imports(as % of merchandise exports) of Ethiopia in 2002 and the Imports(as % of merchandise exports) of Portugal in 2005?
Your answer should be very brief. -0.64. What is the difference between the Imports(as % of merchandise exports) of Ethiopia in 2002 and the Imports(as % of merchandise exports) of United States in 2005?
Provide a short and direct response. -0.43. What is the difference between the Imports(as % of merchandise exports) of Finland in 2002 and the Imports(as % of merchandise exports) of Portugal in 2005?
Your answer should be compact. 1.22. What is the difference between the Imports(as % of merchandise exports) of Finland in 2002 and the Imports(as % of merchandise exports) of United States in 2005?
Your answer should be very brief. 1.43. What is the difference between the Imports(as % of merchandise exports) in Portugal in 2002 and the Imports(as % of merchandise exports) in United States in 2005?
Make the answer very short. 0.96. What is the difference between the Imports(as % of merchandise exports) of Ethiopia in 2003 and the Imports(as % of merchandise exports) of Finland in 2004?
Keep it short and to the point. -1.91. What is the difference between the Imports(as % of merchandise exports) of Ethiopia in 2003 and the Imports(as % of merchandise exports) of Portugal in 2004?
Keep it short and to the point. -0.87. What is the difference between the Imports(as % of merchandise exports) of Ethiopia in 2003 and the Imports(as % of merchandise exports) of United States in 2004?
Your answer should be compact. -0.68. What is the difference between the Imports(as % of merchandise exports) of Finland in 2003 and the Imports(as % of merchandise exports) of Portugal in 2004?
Keep it short and to the point. 1.11. What is the difference between the Imports(as % of merchandise exports) of Finland in 2003 and the Imports(as % of merchandise exports) of United States in 2004?
Provide a succinct answer. 1.3. What is the difference between the Imports(as % of merchandise exports) of Portugal in 2003 and the Imports(as % of merchandise exports) of United States in 2004?
Provide a short and direct response. 0.78. What is the difference between the Imports(as % of merchandise exports) in Ethiopia in 2003 and the Imports(as % of merchandise exports) in Finland in 2005?
Offer a terse response. -2.01. What is the difference between the Imports(as % of merchandise exports) of Ethiopia in 2003 and the Imports(as % of merchandise exports) of Portugal in 2005?
Ensure brevity in your answer.  -0.81. What is the difference between the Imports(as % of merchandise exports) of Ethiopia in 2003 and the Imports(as % of merchandise exports) of United States in 2005?
Make the answer very short. -0.6. What is the difference between the Imports(as % of merchandise exports) in Finland in 2003 and the Imports(as % of merchandise exports) in Portugal in 2005?
Your answer should be very brief. 1.17. What is the difference between the Imports(as % of merchandise exports) of Finland in 2003 and the Imports(as % of merchandise exports) of United States in 2005?
Ensure brevity in your answer.  1.38. What is the difference between the Imports(as % of merchandise exports) in Portugal in 2003 and the Imports(as % of merchandise exports) in United States in 2005?
Offer a very short reply. 0.86. What is the difference between the Imports(as % of merchandise exports) of Ethiopia in 2004 and the Imports(as % of merchandise exports) of Finland in 2005?
Offer a very short reply. -1.84. What is the difference between the Imports(as % of merchandise exports) in Ethiopia in 2004 and the Imports(as % of merchandise exports) in Portugal in 2005?
Ensure brevity in your answer.  -0.64. What is the difference between the Imports(as % of merchandise exports) of Ethiopia in 2004 and the Imports(as % of merchandise exports) of United States in 2005?
Your response must be concise. -0.43. What is the difference between the Imports(as % of merchandise exports) in Finland in 2004 and the Imports(as % of merchandise exports) in Portugal in 2005?
Give a very brief answer. 1.11. What is the difference between the Imports(as % of merchandise exports) of Finland in 2004 and the Imports(as % of merchandise exports) of United States in 2005?
Make the answer very short. 1.32. What is the difference between the Imports(as % of merchandise exports) of Portugal in 2004 and the Imports(as % of merchandise exports) of United States in 2005?
Give a very brief answer. 0.27. What is the average Imports(as % of merchandise exports) of Ethiopia per year?
Provide a succinct answer. 1.03. What is the average Imports(as % of merchandise exports) in Finland per year?
Provide a succinct answer. 2.63. What is the average Imports(as % of merchandise exports) of Portugal per year?
Keep it short and to the point. 2.29. What is the average Imports(as % of merchandise exports) of United States per year?
Keep it short and to the point. 1.45. In the year 1998, what is the difference between the Imports(as % of merchandise exports) of Ethiopia and Imports(as % of merchandise exports) of Finland?
Provide a short and direct response. -1.34. In the year 1998, what is the difference between the Imports(as % of merchandise exports) of Ethiopia and Imports(as % of merchandise exports) of Portugal?
Ensure brevity in your answer.  -1.92. In the year 1998, what is the difference between the Imports(as % of merchandise exports) of Ethiopia and Imports(as % of merchandise exports) of United States?
Your response must be concise. -0.43. In the year 1998, what is the difference between the Imports(as % of merchandise exports) of Finland and Imports(as % of merchandise exports) of Portugal?
Your response must be concise. -0.57. In the year 1998, what is the difference between the Imports(as % of merchandise exports) of Finland and Imports(as % of merchandise exports) of United States?
Offer a terse response. 0.91. In the year 1998, what is the difference between the Imports(as % of merchandise exports) of Portugal and Imports(as % of merchandise exports) of United States?
Your response must be concise. 1.49. In the year 1999, what is the difference between the Imports(as % of merchandise exports) in Ethiopia and Imports(as % of merchandise exports) in Finland?
Provide a short and direct response. -1.34. In the year 1999, what is the difference between the Imports(as % of merchandise exports) in Ethiopia and Imports(as % of merchandise exports) in Portugal?
Keep it short and to the point. -1.33. In the year 1999, what is the difference between the Imports(as % of merchandise exports) of Ethiopia and Imports(as % of merchandise exports) of United States?
Your response must be concise. -0.42. In the year 1999, what is the difference between the Imports(as % of merchandise exports) of Finland and Imports(as % of merchandise exports) of Portugal?
Your answer should be very brief. 0.01. In the year 1999, what is the difference between the Imports(as % of merchandise exports) of Finland and Imports(as % of merchandise exports) of United States?
Your response must be concise. 0.92. In the year 1999, what is the difference between the Imports(as % of merchandise exports) of Portugal and Imports(as % of merchandise exports) of United States?
Your answer should be compact. 0.91. In the year 2000, what is the difference between the Imports(as % of merchandise exports) in Ethiopia and Imports(as % of merchandise exports) in Finland?
Your answer should be compact. -1.06. In the year 2000, what is the difference between the Imports(as % of merchandise exports) of Ethiopia and Imports(as % of merchandise exports) of Portugal?
Ensure brevity in your answer.  -1.32. In the year 2000, what is the difference between the Imports(as % of merchandise exports) of Ethiopia and Imports(as % of merchandise exports) of United States?
Your response must be concise. -0.17. In the year 2000, what is the difference between the Imports(as % of merchandise exports) of Finland and Imports(as % of merchandise exports) of Portugal?
Make the answer very short. -0.26. In the year 2000, what is the difference between the Imports(as % of merchandise exports) in Finland and Imports(as % of merchandise exports) in United States?
Offer a very short reply. 0.88. In the year 2000, what is the difference between the Imports(as % of merchandise exports) of Portugal and Imports(as % of merchandise exports) of United States?
Give a very brief answer. 1.14. In the year 2001, what is the difference between the Imports(as % of merchandise exports) in Ethiopia and Imports(as % of merchandise exports) in Finland?
Your answer should be very brief. -1.65. In the year 2001, what is the difference between the Imports(as % of merchandise exports) of Ethiopia and Imports(as % of merchandise exports) of Portugal?
Keep it short and to the point. -1.36. In the year 2001, what is the difference between the Imports(as % of merchandise exports) in Ethiopia and Imports(as % of merchandise exports) in United States?
Offer a terse response. -0.38. In the year 2001, what is the difference between the Imports(as % of merchandise exports) in Finland and Imports(as % of merchandise exports) in Portugal?
Give a very brief answer. 0.29. In the year 2001, what is the difference between the Imports(as % of merchandise exports) of Finland and Imports(as % of merchandise exports) of United States?
Provide a short and direct response. 1.27. In the year 2001, what is the difference between the Imports(as % of merchandise exports) of Portugal and Imports(as % of merchandise exports) of United States?
Your answer should be compact. 0.98. In the year 2002, what is the difference between the Imports(as % of merchandise exports) in Ethiopia and Imports(as % of merchandise exports) in Finland?
Provide a succinct answer. -1.86. In the year 2002, what is the difference between the Imports(as % of merchandise exports) of Ethiopia and Imports(as % of merchandise exports) of Portugal?
Keep it short and to the point. -1.39. In the year 2002, what is the difference between the Imports(as % of merchandise exports) of Ethiopia and Imports(as % of merchandise exports) of United States?
Ensure brevity in your answer.  -0.46. In the year 2002, what is the difference between the Imports(as % of merchandise exports) in Finland and Imports(as % of merchandise exports) in Portugal?
Ensure brevity in your answer.  0.48. In the year 2002, what is the difference between the Imports(as % of merchandise exports) of Finland and Imports(as % of merchandise exports) of United States?
Make the answer very short. 1.4. In the year 2002, what is the difference between the Imports(as % of merchandise exports) of Portugal and Imports(as % of merchandise exports) of United States?
Your answer should be compact. 0.92. In the year 2003, what is the difference between the Imports(as % of merchandise exports) in Ethiopia and Imports(as % of merchandise exports) in Finland?
Ensure brevity in your answer.  -1.98. In the year 2003, what is the difference between the Imports(as % of merchandise exports) of Ethiopia and Imports(as % of merchandise exports) of Portugal?
Keep it short and to the point. -1.46. In the year 2003, what is the difference between the Imports(as % of merchandise exports) of Ethiopia and Imports(as % of merchandise exports) of United States?
Give a very brief answer. -0.54. In the year 2003, what is the difference between the Imports(as % of merchandise exports) in Finland and Imports(as % of merchandise exports) in Portugal?
Provide a succinct answer. 0.52. In the year 2003, what is the difference between the Imports(as % of merchandise exports) of Finland and Imports(as % of merchandise exports) of United States?
Make the answer very short. 1.44. In the year 2003, what is the difference between the Imports(as % of merchandise exports) in Portugal and Imports(as % of merchandise exports) in United States?
Ensure brevity in your answer.  0.92. In the year 2004, what is the difference between the Imports(as % of merchandise exports) in Ethiopia and Imports(as % of merchandise exports) in Finland?
Offer a terse response. -1.75. In the year 2004, what is the difference between the Imports(as % of merchandise exports) in Ethiopia and Imports(as % of merchandise exports) in Portugal?
Your response must be concise. -0.7. In the year 2004, what is the difference between the Imports(as % of merchandise exports) of Ethiopia and Imports(as % of merchandise exports) of United States?
Your answer should be compact. -0.51. In the year 2004, what is the difference between the Imports(as % of merchandise exports) of Finland and Imports(as % of merchandise exports) of Portugal?
Your answer should be very brief. 1.04. In the year 2004, what is the difference between the Imports(as % of merchandise exports) of Finland and Imports(as % of merchandise exports) of United States?
Your answer should be very brief. 1.24. In the year 2004, what is the difference between the Imports(as % of merchandise exports) in Portugal and Imports(as % of merchandise exports) in United States?
Offer a very short reply. 0.19. In the year 2005, what is the difference between the Imports(as % of merchandise exports) in Ethiopia and Imports(as % of merchandise exports) in Finland?
Make the answer very short. -1.81. In the year 2005, what is the difference between the Imports(as % of merchandise exports) of Ethiopia and Imports(as % of merchandise exports) of Portugal?
Provide a short and direct response. -0.61. In the year 2005, what is the difference between the Imports(as % of merchandise exports) of Ethiopia and Imports(as % of merchandise exports) of United States?
Ensure brevity in your answer.  -0.4. In the year 2005, what is the difference between the Imports(as % of merchandise exports) in Finland and Imports(as % of merchandise exports) in Portugal?
Your answer should be very brief. 1.2. In the year 2005, what is the difference between the Imports(as % of merchandise exports) in Finland and Imports(as % of merchandise exports) in United States?
Your answer should be compact. 1.41. In the year 2005, what is the difference between the Imports(as % of merchandise exports) of Portugal and Imports(as % of merchandise exports) of United States?
Your answer should be very brief. 0.21. What is the ratio of the Imports(as % of merchandise exports) in Ethiopia in 1998 to that in 1999?
Ensure brevity in your answer.  1.05. What is the ratio of the Imports(as % of merchandise exports) of Finland in 1998 to that in 1999?
Your answer should be very brief. 1.03. What is the ratio of the Imports(as % of merchandise exports) in Portugal in 1998 to that in 1999?
Ensure brevity in your answer.  1.25. What is the ratio of the Imports(as % of merchandise exports) of United States in 1998 to that in 1999?
Make the answer very short. 1.05. What is the ratio of the Imports(as % of merchandise exports) of Ethiopia in 1998 to that in 2000?
Your answer should be compact. 1.04. What is the ratio of the Imports(as % of merchandise exports) of Finland in 1998 to that in 2000?
Provide a succinct answer. 1.15. What is the ratio of the Imports(as % of merchandise exports) of Portugal in 1998 to that in 2000?
Your answer should be compact. 1.25. What is the ratio of the Imports(as % of merchandise exports) of United States in 1998 to that in 2000?
Offer a very short reply. 1.22. What is the ratio of the Imports(as % of merchandise exports) of Ethiopia in 1998 to that in 2001?
Offer a very short reply. 1.28. What is the ratio of the Imports(as % of merchandise exports) of Portugal in 1998 to that in 2001?
Your response must be concise. 1.35. What is the ratio of the Imports(as % of merchandise exports) in United States in 1998 to that in 2001?
Provide a succinct answer. 1.24. What is the ratio of the Imports(as % of merchandise exports) in Ethiopia in 1998 to that in 2002?
Keep it short and to the point. 1.45. What is the ratio of the Imports(as % of merchandise exports) of Finland in 1998 to that in 2002?
Provide a short and direct response. 0.96. What is the ratio of the Imports(as % of merchandise exports) in Portugal in 1998 to that in 2002?
Offer a terse response. 1.41. What is the ratio of the Imports(as % of merchandise exports) in United States in 1998 to that in 2002?
Your answer should be very brief. 1.27. What is the ratio of the Imports(as % of merchandise exports) in Ethiopia in 1998 to that in 2003?
Offer a very short reply. 1.79. What is the ratio of the Imports(as % of merchandise exports) of Finland in 1998 to that in 2003?
Make the answer very short. 0.98. What is the ratio of the Imports(as % of merchandise exports) in Portugal in 1998 to that in 2003?
Give a very brief answer. 1.47. What is the ratio of the Imports(as % of merchandise exports) of United States in 1998 to that in 2003?
Give a very brief answer. 1.37. What is the ratio of the Imports(as % of merchandise exports) of Ethiopia in 1998 to that in 2004?
Provide a succinct answer. 1.46. What is the ratio of the Imports(as % of merchandise exports) of Finland in 1998 to that in 2004?
Keep it short and to the point. 1. What is the ratio of the Imports(as % of merchandise exports) of Portugal in 1998 to that in 2004?
Give a very brief answer. 2.02. What is the ratio of the Imports(as % of merchandise exports) of United States in 1998 to that in 2004?
Give a very brief answer. 1.23. What is the ratio of the Imports(as % of merchandise exports) of Ethiopia in 1998 to that in 2005?
Your answer should be very brief. 1.41. What is the ratio of the Imports(as % of merchandise exports) of Finland in 1998 to that in 2005?
Your answer should be very brief. 0.97. What is the ratio of the Imports(as % of merchandise exports) in Portugal in 1998 to that in 2005?
Provide a short and direct response. 2.1. What is the ratio of the Imports(as % of merchandise exports) in United States in 1998 to that in 2005?
Offer a very short reply. 1.31. What is the ratio of the Imports(as % of merchandise exports) of Finland in 1999 to that in 2000?
Provide a short and direct response. 1.12. What is the ratio of the Imports(as % of merchandise exports) of United States in 1999 to that in 2000?
Provide a succinct answer. 1.16. What is the ratio of the Imports(as % of merchandise exports) in Ethiopia in 1999 to that in 2001?
Make the answer very short. 1.21. What is the ratio of the Imports(as % of merchandise exports) in Finland in 1999 to that in 2001?
Provide a succinct answer. 0.97. What is the ratio of the Imports(as % of merchandise exports) in Portugal in 1999 to that in 2001?
Ensure brevity in your answer.  1.08. What is the ratio of the Imports(as % of merchandise exports) in United States in 1999 to that in 2001?
Give a very brief answer. 1.18. What is the ratio of the Imports(as % of merchandise exports) in Ethiopia in 1999 to that in 2002?
Provide a succinct answer. 1.38. What is the ratio of the Imports(as % of merchandise exports) in Finland in 1999 to that in 2002?
Provide a succinct answer. 0.93. What is the ratio of the Imports(as % of merchandise exports) of Portugal in 1999 to that in 2002?
Ensure brevity in your answer.  1.13. What is the ratio of the Imports(as % of merchandise exports) of United States in 1999 to that in 2002?
Ensure brevity in your answer.  1.22. What is the ratio of the Imports(as % of merchandise exports) of Ethiopia in 1999 to that in 2003?
Provide a succinct answer. 1.71. What is the ratio of the Imports(as % of merchandise exports) in Finland in 1999 to that in 2003?
Offer a terse response. 0.95. What is the ratio of the Imports(as % of merchandise exports) in Portugal in 1999 to that in 2003?
Offer a terse response. 1.18. What is the ratio of the Imports(as % of merchandise exports) in United States in 1999 to that in 2003?
Offer a terse response. 1.31. What is the ratio of the Imports(as % of merchandise exports) of Ethiopia in 1999 to that in 2004?
Give a very brief answer. 1.39. What is the ratio of the Imports(as % of merchandise exports) of Finland in 1999 to that in 2004?
Give a very brief answer. 0.98. What is the ratio of the Imports(as % of merchandise exports) in Portugal in 1999 to that in 2004?
Your response must be concise. 1.61. What is the ratio of the Imports(as % of merchandise exports) in United States in 1999 to that in 2004?
Offer a very short reply. 1.18. What is the ratio of the Imports(as % of merchandise exports) in Ethiopia in 1999 to that in 2005?
Your answer should be very brief. 1.34. What is the ratio of the Imports(as % of merchandise exports) in Finland in 1999 to that in 2005?
Keep it short and to the point. 0.94. What is the ratio of the Imports(as % of merchandise exports) of Portugal in 1999 to that in 2005?
Provide a succinct answer. 1.67. What is the ratio of the Imports(as % of merchandise exports) of United States in 1999 to that in 2005?
Offer a terse response. 1.25. What is the ratio of the Imports(as % of merchandise exports) of Ethiopia in 2000 to that in 2001?
Ensure brevity in your answer.  1.22. What is the ratio of the Imports(as % of merchandise exports) in Finland in 2000 to that in 2001?
Your response must be concise. 0.86. What is the ratio of the Imports(as % of merchandise exports) of Portugal in 2000 to that in 2001?
Provide a succinct answer. 1.08. What is the ratio of the Imports(as % of merchandise exports) in United States in 2000 to that in 2001?
Offer a very short reply. 1.02. What is the ratio of the Imports(as % of merchandise exports) in Ethiopia in 2000 to that in 2002?
Offer a terse response. 1.4. What is the ratio of the Imports(as % of merchandise exports) in Finland in 2000 to that in 2002?
Offer a very short reply. 0.84. What is the ratio of the Imports(as % of merchandise exports) of Portugal in 2000 to that in 2002?
Your answer should be compact. 1.13. What is the ratio of the Imports(as % of merchandise exports) of United States in 2000 to that in 2002?
Keep it short and to the point. 1.05. What is the ratio of the Imports(as % of merchandise exports) in Ethiopia in 2000 to that in 2003?
Offer a very short reply. 1.72. What is the ratio of the Imports(as % of merchandise exports) of Finland in 2000 to that in 2003?
Your answer should be very brief. 0.85. What is the ratio of the Imports(as % of merchandise exports) of Portugal in 2000 to that in 2003?
Ensure brevity in your answer.  1.18. What is the ratio of the Imports(as % of merchandise exports) in United States in 2000 to that in 2003?
Keep it short and to the point. 1.12. What is the ratio of the Imports(as % of merchandise exports) in Ethiopia in 2000 to that in 2004?
Your response must be concise. 1.4. What is the ratio of the Imports(as % of merchandise exports) of Finland in 2000 to that in 2004?
Provide a short and direct response. 0.87. What is the ratio of the Imports(as % of merchandise exports) of Portugal in 2000 to that in 2004?
Keep it short and to the point. 1.61. What is the ratio of the Imports(as % of merchandise exports) of United States in 2000 to that in 2004?
Give a very brief answer. 1.01. What is the ratio of the Imports(as % of merchandise exports) in Ethiopia in 2000 to that in 2005?
Give a very brief answer. 1.35. What is the ratio of the Imports(as % of merchandise exports) of Finland in 2000 to that in 2005?
Offer a very short reply. 0.84. What is the ratio of the Imports(as % of merchandise exports) in Portugal in 2000 to that in 2005?
Give a very brief answer. 1.67. What is the ratio of the Imports(as % of merchandise exports) of United States in 2000 to that in 2005?
Provide a succinct answer. 1.07. What is the ratio of the Imports(as % of merchandise exports) in Ethiopia in 2001 to that in 2002?
Make the answer very short. 1.14. What is the ratio of the Imports(as % of merchandise exports) of Finland in 2001 to that in 2002?
Keep it short and to the point. 0.97. What is the ratio of the Imports(as % of merchandise exports) in Portugal in 2001 to that in 2002?
Ensure brevity in your answer.  1.04. What is the ratio of the Imports(as % of merchandise exports) of United States in 2001 to that in 2002?
Your answer should be very brief. 1.03. What is the ratio of the Imports(as % of merchandise exports) in Ethiopia in 2001 to that in 2003?
Keep it short and to the point. 1.41. What is the ratio of the Imports(as % of merchandise exports) in Finland in 2001 to that in 2003?
Your answer should be very brief. 0.99. What is the ratio of the Imports(as % of merchandise exports) of Portugal in 2001 to that in 2003?
Make the answer very short. 1.09. What is the ratio of the Imports(as % of merchandise exports) of United States in 2001 to that in 2003?
Your answer should be compact. 1.1. What is the ratio of the Imports(as % of merchandise exports) in Ethiopia in 2001 to that in 2004?
Give a very brief answer. 1.14. What is the ratio of the Imports(as % of merchandise exports) in Finland in 2001 to that in 2004?
Provide a succinct answer. 1.01. What is the ratio of the Imports(as % of merchandise exports) of Portugal in 2001 to that in 2004?
Give a very brief answer. 1.49. What is the ratio of the Imports(as % of merchandise exports) in Ethiopia in 2001 to that in 2005?
Offer a very short reply. 1.1. What is the ratio of the Imports(as % of merchandise exports) of Finland in 2001 to that in 2005?
Your answer should be compact. 0.97. What is the ratio of the Imports(as % of merchandise exports) of Portugal in 2001 to that in 2005?
Provide a succinct answer. 1.55. What is the ratio of the Imports(as % of merchandise exports) of United States in 2001 to that in 2005?
Give a very brief answer. 1.06. What is the ratio of the Imports(as % of merchandise exports) of Ethiopia in 2002 to that in 2003?
Your response must be concise. 1.23. What is the ratio of the Imports(as % of merchandise exports) in Finland in 2002 to that in 2003?
Give a very brief answer. 1.02. What is the ratio of the Imports(as % of merchandise exports) of Portugal in 2002 to that in 2003?
Offer a terse response. 1.04. What is the ratio of the Imports(as % of merchandise exports) of United States in 2002 to that in 2003?
Your answer should be compact. 1.07. What is the ratio of the Imports(as % of merchandise exports) in Ethiopia in 2002 to that in 2004?
Your answer should be very brief. 1. What is the ratio of the Imports(as % of merchandise exports) in Finland in 2002 to that in 2004?
Give a very brief answer. 1.04. What is the ratio of the Imports(as % of merchandise exports) in Portugal in 2002 to that in 2004?
Make the answer very short. 1.43. What is the ratio of the Imports(as % of merchandise exports) of United States in 2002 to that in 2004?
Offer a very short reply. 0.97. What is the ratio of the Imports(as % of merchandise exports) of Ethiopia in 2002 to that in 2005?
Your answer should be very brief. 0.97. What is the ratio of the Imports(as % of merchandise exports) of Portugal in 2002 to that in 2005?
Your response must be concise. 1.49. What is the ratio of the Imports(as % of merchandise exports) in United States in 2002 to that in 2005?
Provide a succinct answer. 1.03. What is the ratio of the Imports(as % of merchandise exports) of Ethiopia in 2003 to that in 2004?
Offer a terse response. 0.81. What is the ratio of the Imports(as % of merchandise exports) in Finland in 2003 to that in 2004?
Your response must be concise. 1.02. What is the ratio of the Imports(as % of merchandise exports) of Portugal in 2003 to that in 2004?
Your answer should be compact. 1.37. What is the ratio of the Imports(as % of merchandise exports) of United States in 2003 to that in 2004?
Make the answer very short. 0.9. What is the ratio of the Imports(as % of merchandise exports) of Ethiopia in 2003 to that in 2005?
Offer a very short reply. 0.79. What is the ratio of the Imports(as % of merchandise exports) of Finland in 2003 to that in 2005?
Keep it short and to the point. 0.99. What is the ratio of the Imports(as % of merchandise exports) in Portugal in 2003 to that in 2005?
Make the answer very short. 1.42. What is the ratio of the Imports(as % of merchandise exports) of United States in 2003 to that in 2005?
Provide a short and direct response. 0.96. What is the ratio of the Imports(as % of merchandise exports) of Ethiopia in 2004 to that in 2005?
Give a very brief answer. 0.97. What is the ratio of the Imports(as % of merchandise exports) of Finland in 2004 to that in 2005?
Your answer should be very brief. 0.96. What is the ratio of the Imports(as % of merchandise exports) in Portugal in 2004 to that in 2005?
Keep it short and to the point. 1.04. What is the ratio of the Imports(as % of merchandise exports) of United States in 2004 to that in 2005?
Your response must be concise. 1.06. What is the difference between the highest and the second highest Imports(as % of merchandise exports) in Ethiopia?
Your answer should be very brief. 0.05. What is the difference between the highest and the second highest Imports(as % of merchandise exports) in Finland?
Offer a very short reply. 0.02. What is the difference between the highest and the second highest Imports(as % of merchandise exports) in Portugal?
Keep it short and to the point. 0.65. What is the difference between the highest and the second highest Imports(as % of merchandise exports) of United States?
Your answer should be compact. 0.08. What is the difference between the highest and the lowest Imports(as % of merchandise exports) in Ethiopia?
Keep it short and to the point. 0.58. What is the difference between the highest and the lowest Imports(as % of merchandise exports) of Finland?
Offer a very short reply. 0.45. What is the difference between the highest and the lowest Imports(as % of merchandise exports) in Portugal?
Your answer should be compact. 1.68. What is the difference between the highest and the lowest Imports(as % of merchandise exports) of United States?
Give a very brief answer. 0.47. 